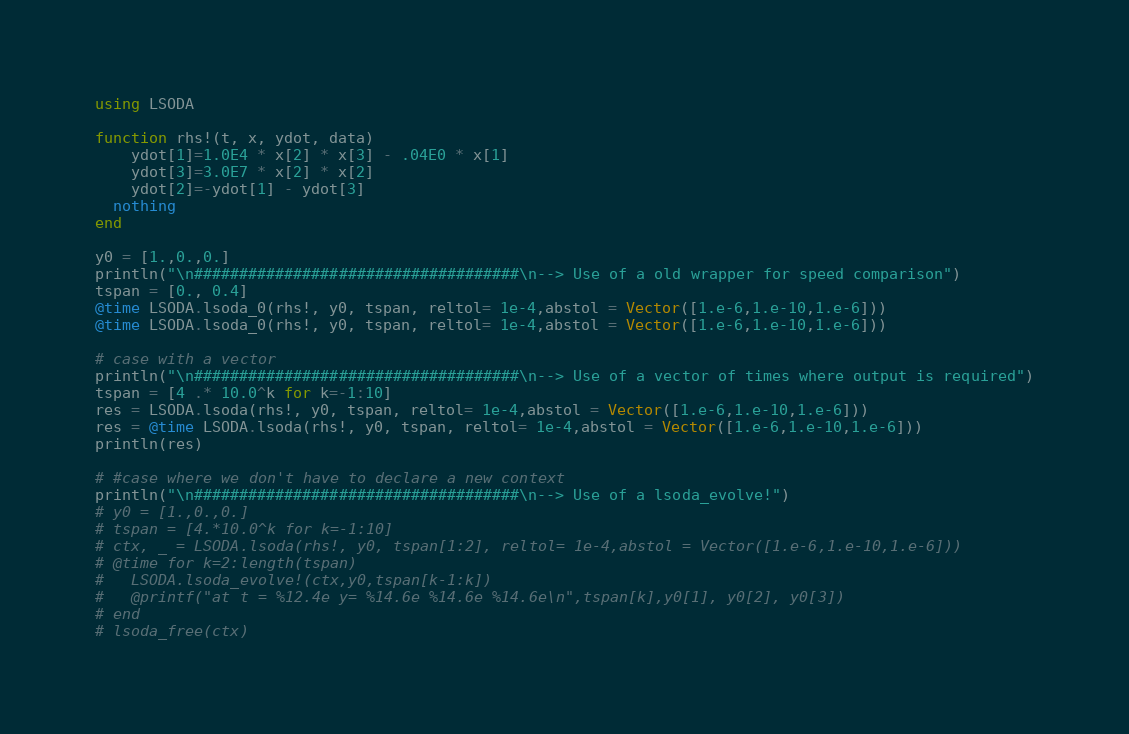<code> <loc_0><loc_0><loc_500><loc_500><_Julia_>using LSODA

function rhs!(t, x, ydot, data)
	ydot[1]=1.0E4 * x[2] * x[3] - .04E0 * x[1]
	ydot[3]=3.0E7 * x[2] * x[2]
	ydot[2]=-ydot[1] - ydot[3]
  nothing
end

y0 = [1.,0.,0.]
println("\n####################################\n--> Use of a old wrapper for speed comparison")
tspan = [0., 0.4]
@time LSODA.lsoda_0(rhs!, y0, tspan, reltol= 1e-4,abstol = Vector([1.e-6,1.e-10,1.e-6]))
@time LSODA.lsoda_0(rhs!, y0, tspan, reltol= 1e-4,abstol = Vector([1.e-6,1.e-10,1.e-6]))

# case with a vector
println("\n####################################\n--> Use of a vector of times where output is required")
tspan = [4 .* 10.0^k for k=-1:10]
res = LSODA.lsoda(rhs!, y0, tspan, reltol= 1e-4,abstol = Vector([1.e-6,1.e-10,1.e-6]))
res = @time LSODA.lsoda(rhs!, y0, tspan, reltol= 1e-4,abstol = Vector([1.e-6,1.e-10,1.e-6]))
println(res)

# #case where we don't have to declare a new context
println("\n####################################\n--> Use of a lsoda_evolve!")
# y0 = [1.,0.,0.]
# tspan = [4.*10.0^k for k=-1:10]
# ctx, _ = LSODA.lsoda(rhs!, y0, tspan[1:2], reltol= 1e-4,abstol = Vector([1.e-6,1.e-10,1.e-6]))
# @time for k=2:length(tspan)
# 	LSODA.lsoda_evolve!(ctx,y0,tspan[k-1:k])
# 	@printf("at t = %12.4e y= %14.6e %14.6e %14.6e\n",tspan[k],y0[1], y0[2], y0[3])
# end
# lsoda_free(ctx)
</code> 